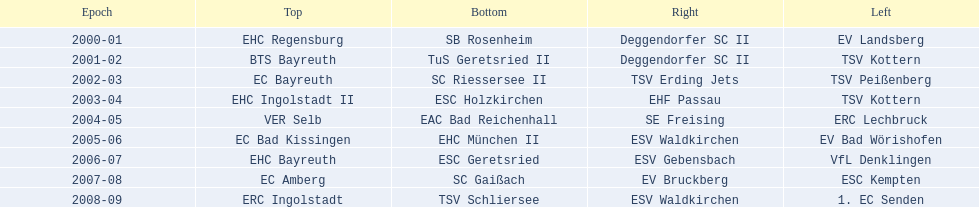How many champions are listend in the north? 9. 